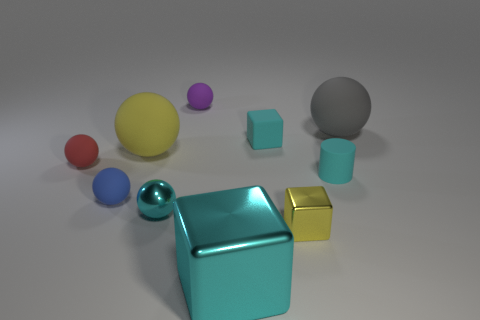How many cubes are big rubber objects or cyan metal things?
Make the answer very short. 1. What number of other objects are there of the same material as the purple ball?
Offer a very short reply. 6. What is the shape of the cyan thing that is behind the cylinder?
Your answer should be very brief. Cube. What material is the tiny ball behind the large matte thing to the right of the yellow rubber sphere?
Provide a succinct answer. Rubber. Are there more big objects behind the gray rubber ball than tiny cyan objects?
Give a very brief answer. No. How many other things are the same color as the small cylinder?
Provide a succinct answer. 3. There is a cyan metallic thing that is the same size as the blue thing; what shape is it?
Offer a very short reply. Sphere. There is a yellow thing to the right of the small matte sphere that is behind the red thing; what number of large rubber balls are left of it?
Offer a terse response. 1. How many metal things are either yellow things or big green things?
Offer a very short reply. 1. The matte ball that is to the right of the yellow rubber object and left of the tiny cyan matte cube is what color?
Offer a terse response. Purple. 